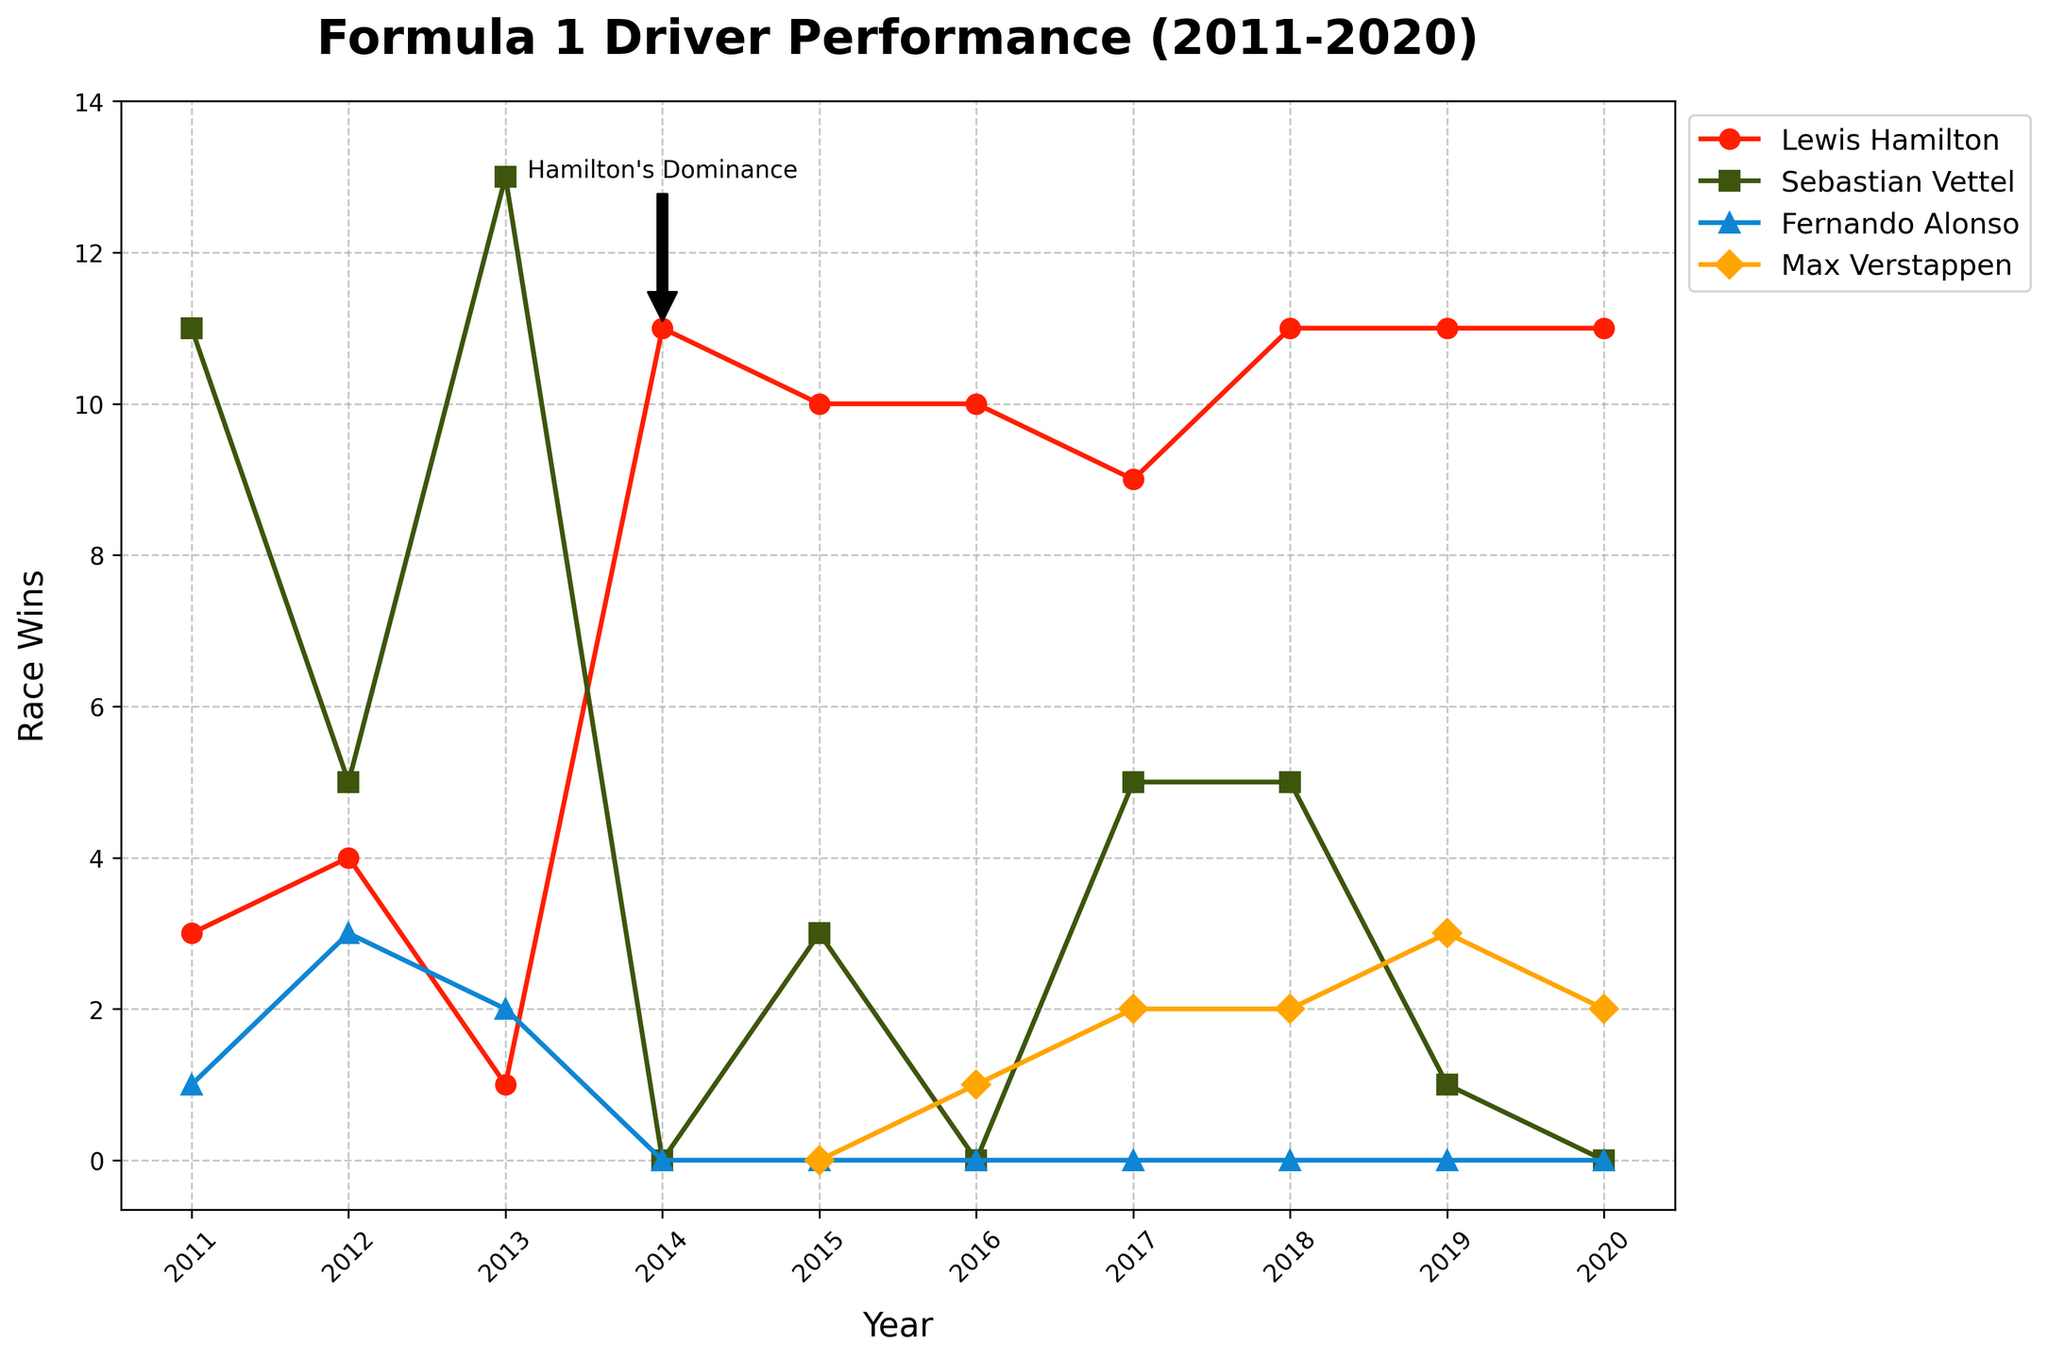What year did Lewis Hamilton achieve the highest number of race wins? Hamilton's highest race wins are represented by the highest point in his line on the chart. This peak occurs at the year labeled 2014, with 11 wins.
Answer: 2014 How many more race wins did Sebastian Vettel have in 2011 compared to Lewis Hamilton in the same year? On the chart, Vettel's line for 2011 is at 11 wins, while Hamilton's is at 3 wins. The difference is 11 - 3.
Answer: 8 Which driver had the most consistent number of race wins from 2017 to 2020? By examining the lines over the years 2017 to 2020, Hamilton's wins stay mostly around 9 to 11 each year, while others fluctuate more.
Answer: Lewis Hamilton Between 2014 and 2015, who had an increase in race wins, and who had a decrease? Looking at the lines from 2014 to 2015, Hamilton decreases from 11 to 10, Vettel increases from 0 to 3, and Alonso stays at 0.
Answer: Vettel increased, Hamilton decreased How many total race wins did Max Verstappen achieve from 2015 to 2020? Summing up the wins (0, 1, 2, 2, 3, 2) from 2015 to 2020 gives 0 + 1 + 2 + 2 + 3 + 2 = 10.
Answer: 10 What visual attribute indicates Hamilton's dominance in the chart? By observing the chart, it's annotated directly with "Hamilton's Dominance" near the highest point on Hamilton's line. The height of his line also visually stands out.
Answer: Hamilton's highest wins and annotation How many more championships did Hamilton win compared to Alonso from 2011 to 2020? The lines showing championship titles in the years indicate that Hamilton won 6 championships, while Alonso won 0. Therefore, 6 - 0 = 6.
Answer: 6 Compare the race wins of Vettel and Hamilton in 2013. Who won more and by how much? In 2013, Vettel's line reaches 13 wins, while Hamilton's is at 1. The difference is 13 - 1.
Answer: Vettel by 12 wins In which year did Vettel have zero race wins for the first time between 2011 to 2020? Observing Vettel's line, the first drop to zero wins occurs in 2014.
Answer: 2014 